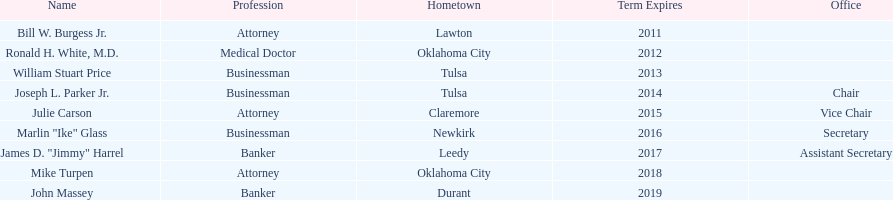How many of the current state regents have a listed office title? 4. 